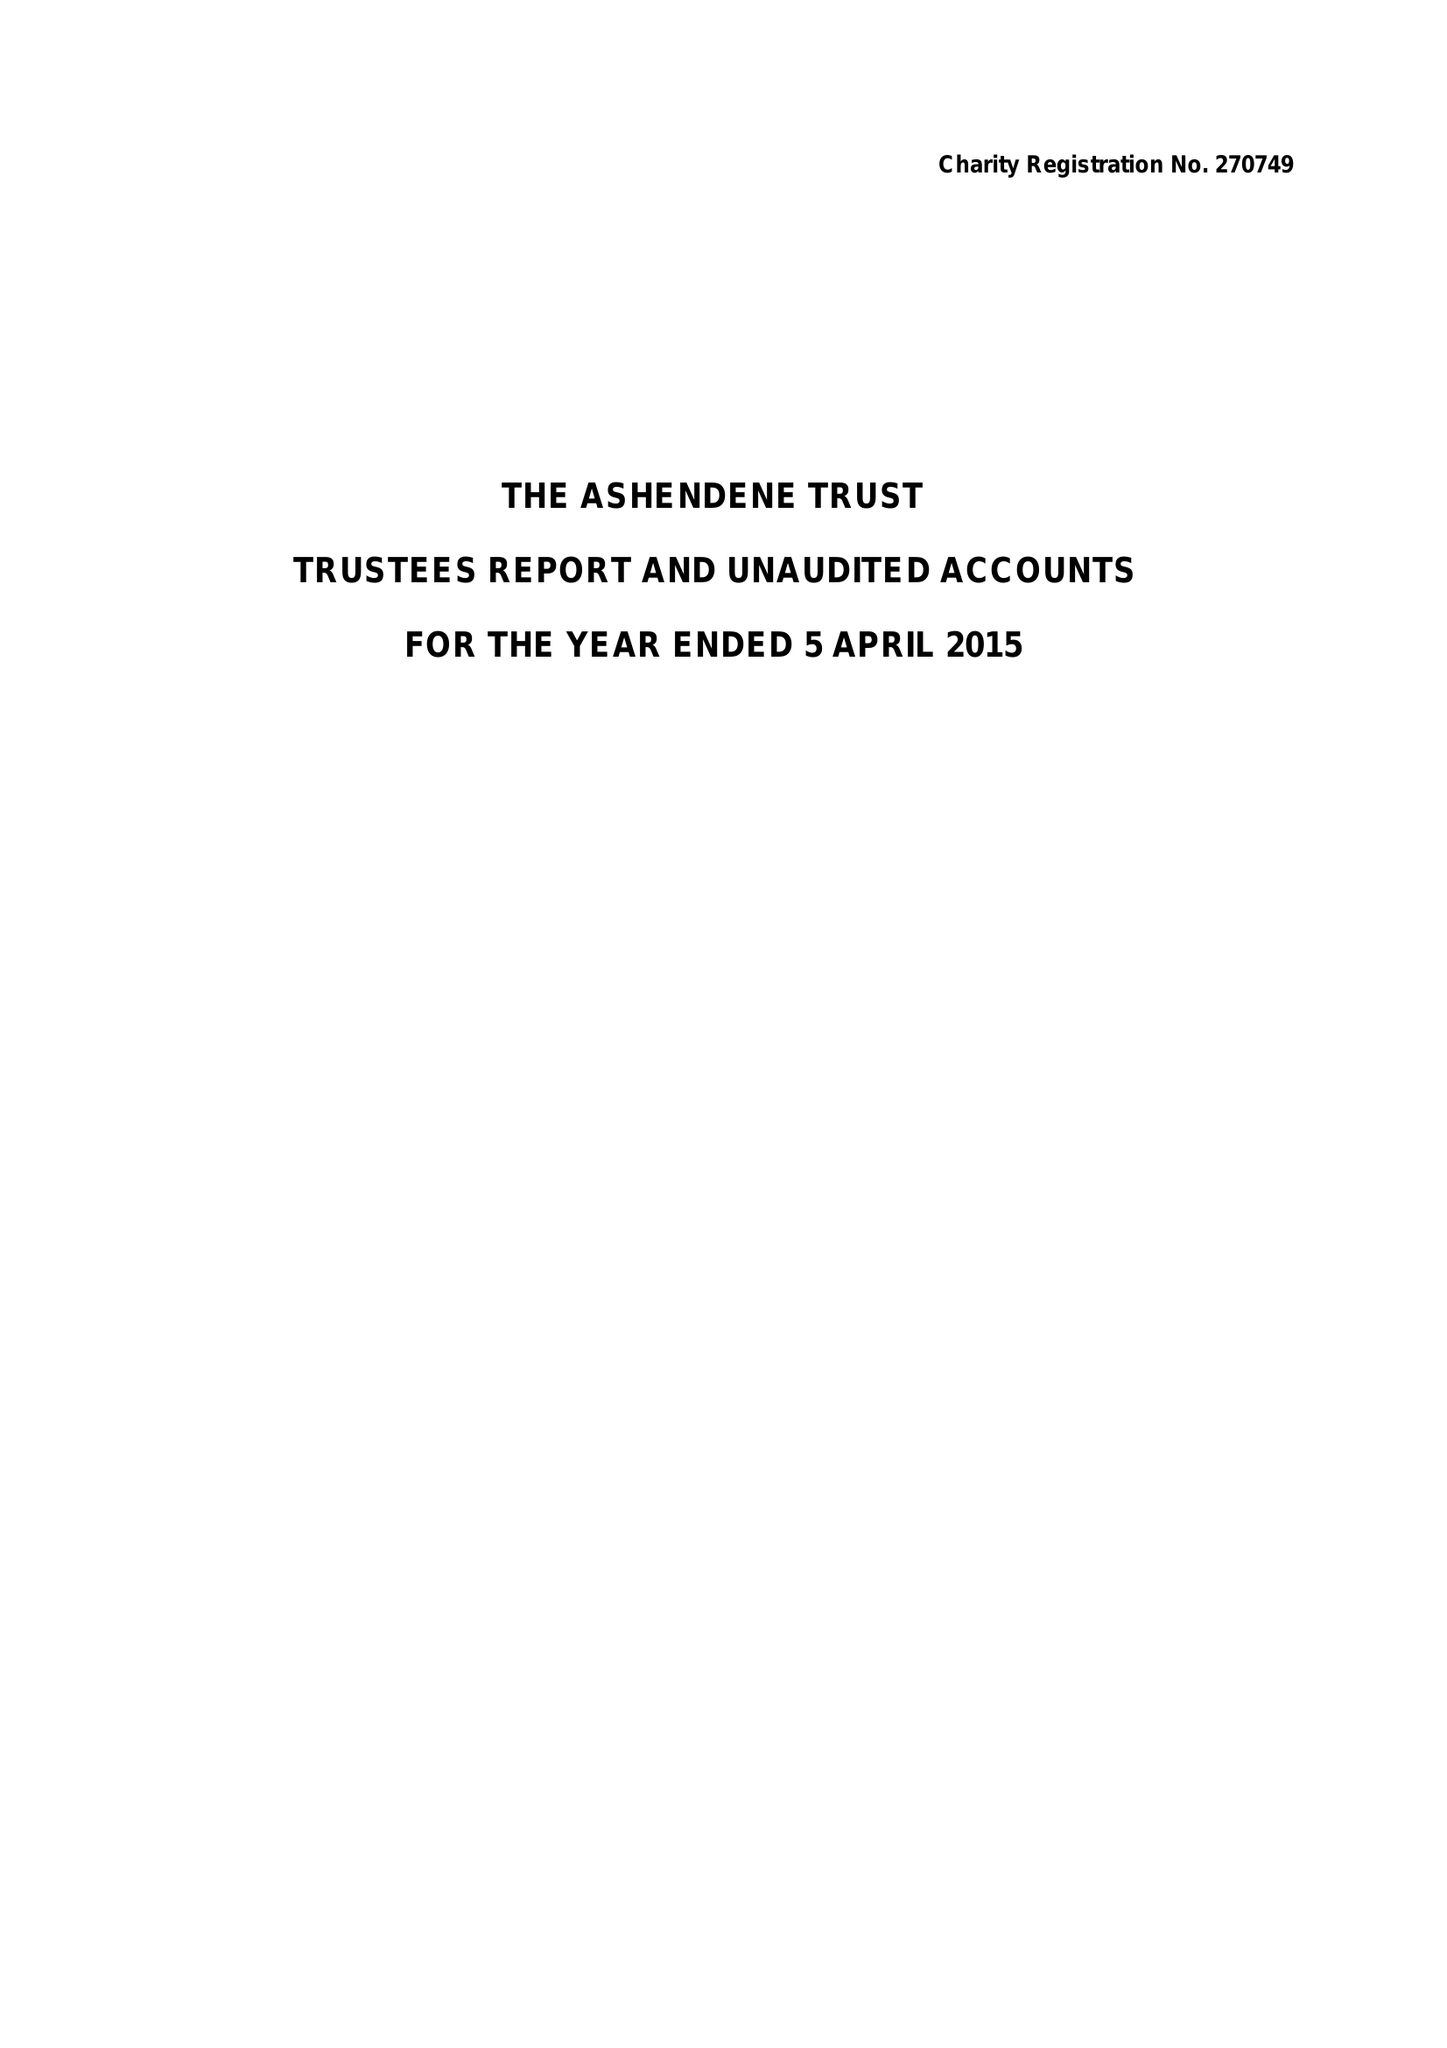What is the value for the income_annually_in_british_pounds?
Answer the question using a single word or phrase. 54852.00 